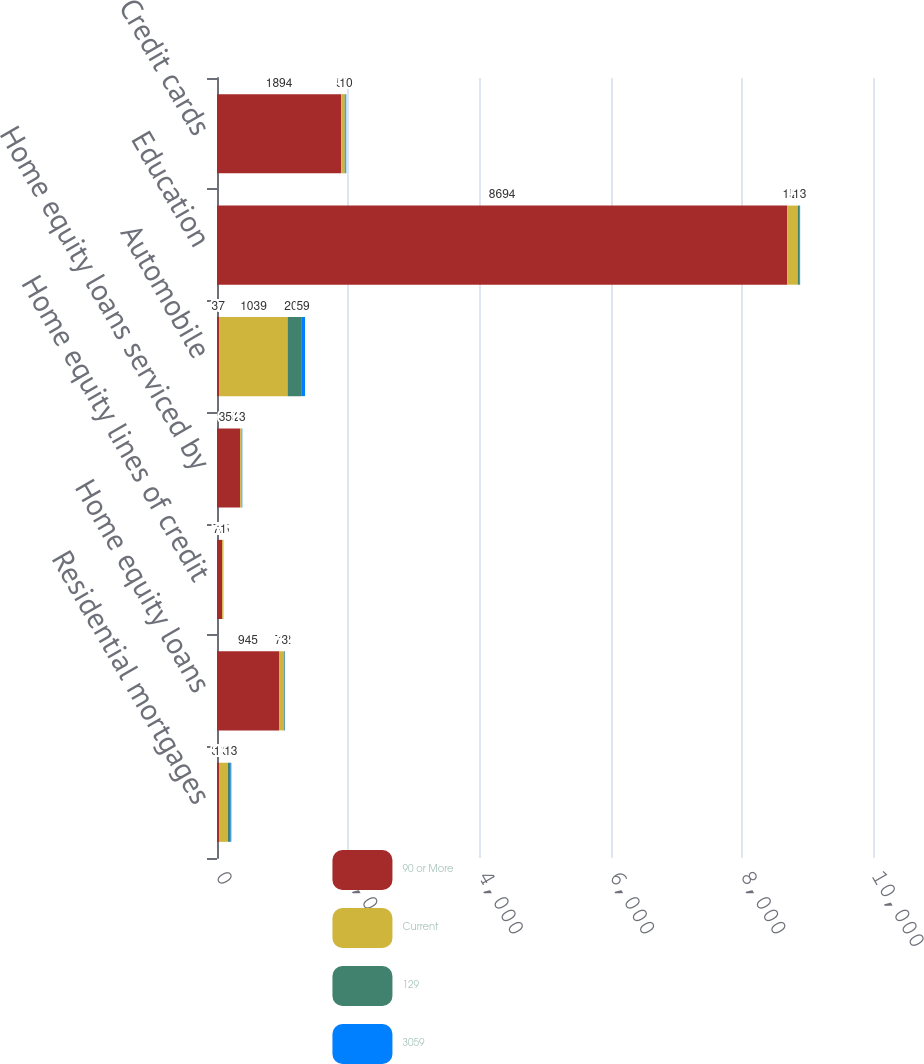Convert chart to OTSL. <chart><loc_0><loc_0><loc_500><loc_500><stacked_bar_chart><ecel><fcel>Residential mortgages<fcel>Home equity loans<fcel>Home equity lines of credit<fcel>Home equity loans serviced by<fcel>Automobile<fcel>Education<fcel>Credit cards<nl><fcel>90 or More<fcel>37<fcel>945<fcel>79<fcel>355<fcel>37<fcel>8694<fcel>1894<nl><fcel>Current<fcel>131<fcel>75<fcel>15<fcel>21<fcel>1039<fcel>159<fcel>53<nl><fcel>129<fcel>37<fcel>12<fcel>2<fcel>7<fcel>207<fcel>23<fcel>14<nl><fcel>3059<fcel>13<fcel>3<fcel>1<fcel>3<fcel>59<fcel>13<fcel>10<nl></chart> 